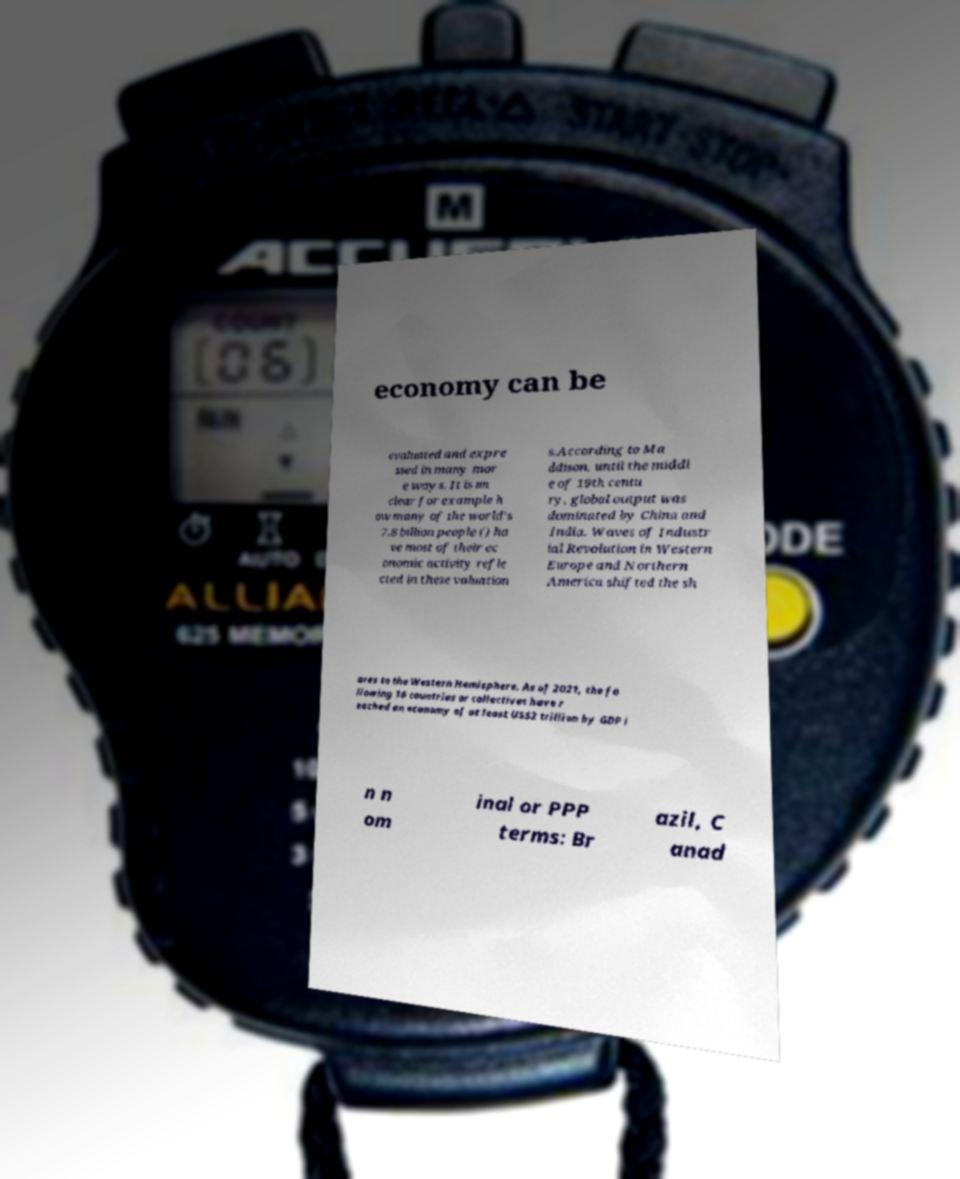I need the written content from this picture converted into text. Can you do that? economy can be evaluated and expre ssed in many mor e ways. It is un clear for example h ow many of the world's 7.8 billion people () ha ve most of their ec onomic activity refle cted in these valuation s.According to Ma ddison, until the middl e of 19th centu ry, global output was dominated by China and India. Waves of Industr ial Revolution in Western Europe and Northern America shifted the sh ares to the Western Hemisphere. As of 2021, the fo llowing 16 countries or collectives have r eached an economy of at least US$2 trillion by GDP i n n om inal or PPP terms: Br azil, C anad 